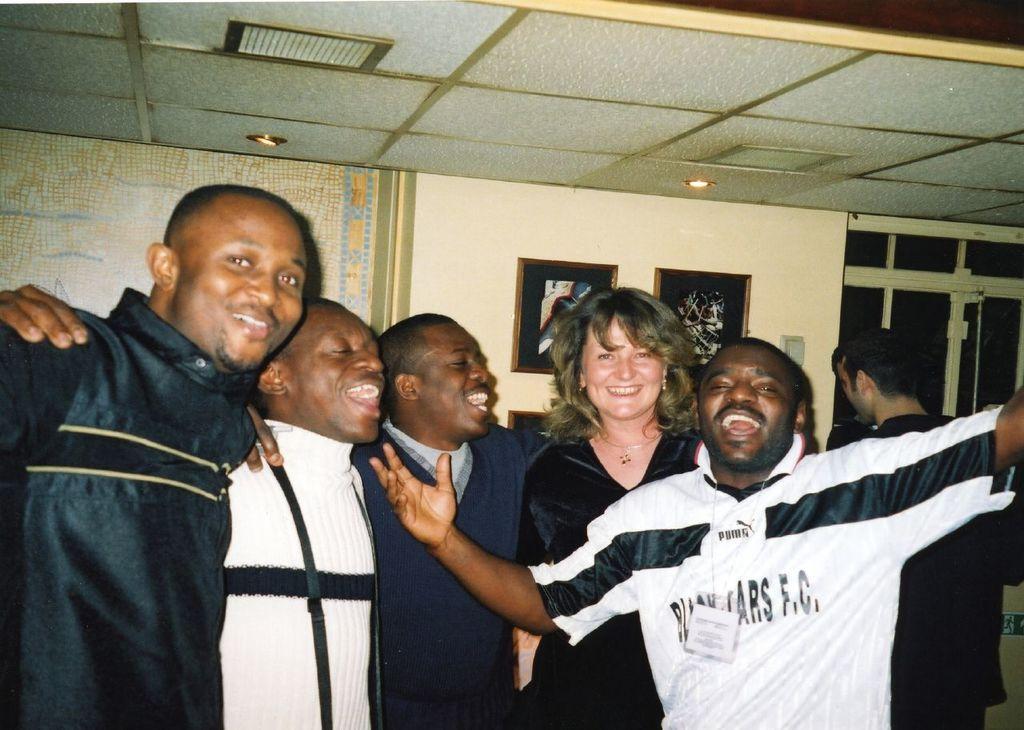In one or two sentences, can you explain what this image depicts? This is an inside view. Here I can see few men and a woman are standing, smiling and giving pose for the picture. On the right side there is another man standing and facing to the back side. At the back of these people there is a wall along with the window. To the wall two frames attached 